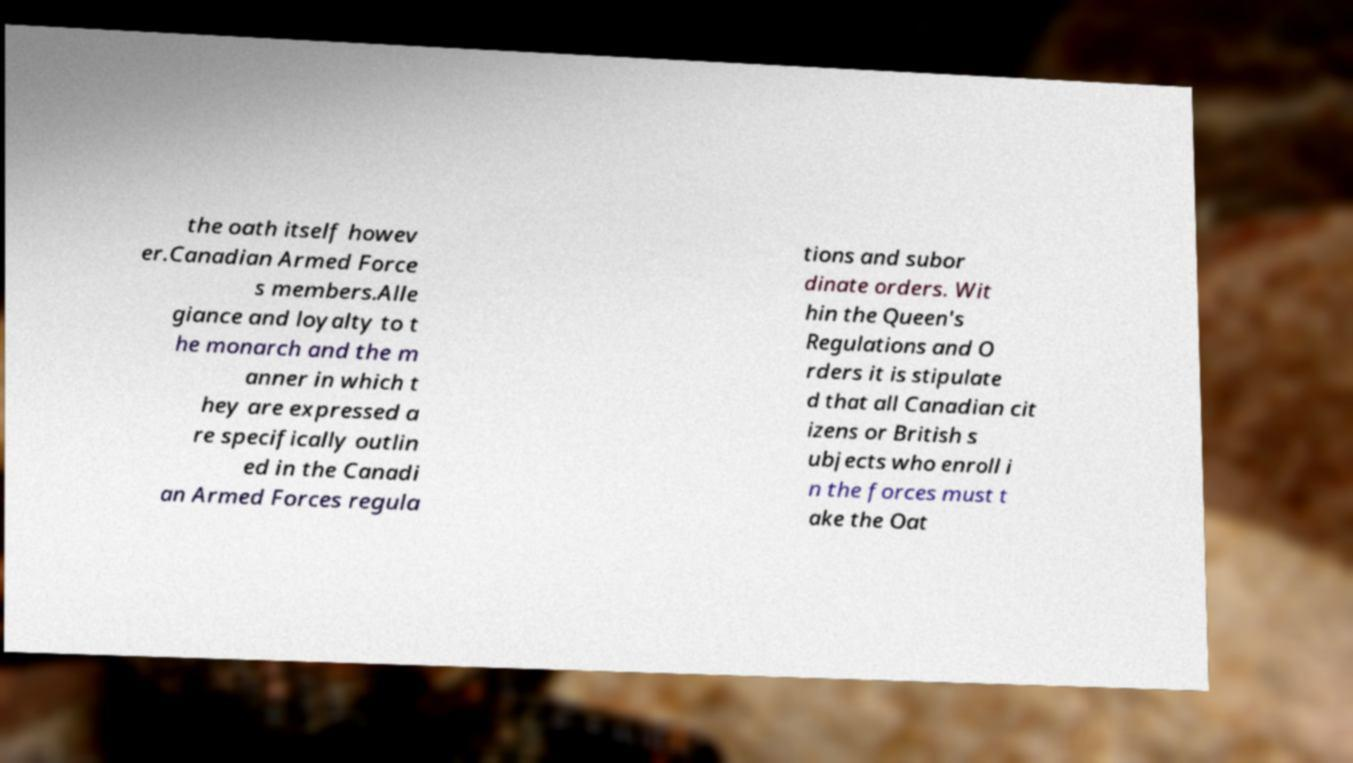Please identify and transcribe the text found in this image. the oath itself howev er.Canadian Armed Force s members.Alle giance and loyalty to t he monarch and the m anner in which t hey are expressed a re specifically outlin ed in the Canadi an Armed Forces regula tions and subor dinate orders. Wit hin the Queen's Regulations and O rders it is stipulate d that all Canadian cit izens or British s ubjects who enroll i n the forces must t ake the Oat 